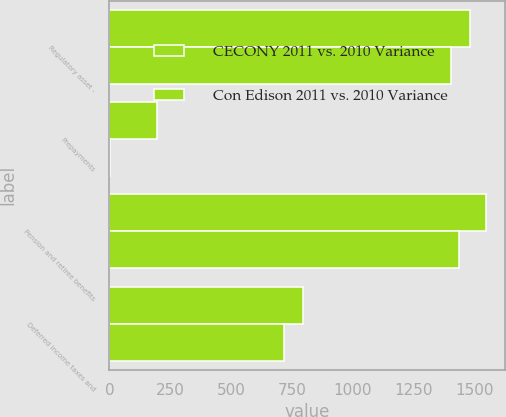<chart> <loc_0><loc_0><loc_500><loc_500><stacked_bar_chart><ecel><fcel>Regulatory asset -<fcel>Prepayments<fcel>Pension and retiree benefits<fcel>Deferred income taxes and<nl><fcel>CECONY 2011 vs. 2010 Variance<fcel>1481<fcel>196<fcel>1548<fcel>794<nl><fcel>Con Edison 2011 vs. 2010 Variance<fcel>1402<fcel>3<fcel>1437<fcel>719<nl></chart> 